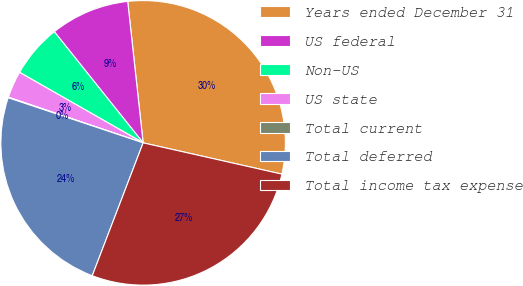Convert chart to OTSL. <chart><loc_0><loc_0><loc_500><loc_500><pie_chart><fcel>Years ended December 31<fcel>US federal<fcel>Non-US<fcel>US state<fcel>Total current<fcel>Total deferred<fcel>Total income tax expense<nl><fcel>30.26%<fcel>9.0%<fcel>6.02%<fcel>3.05%<fcel>0.07%<fcel>24.31%<fcel>27.29%<nl></chart> 